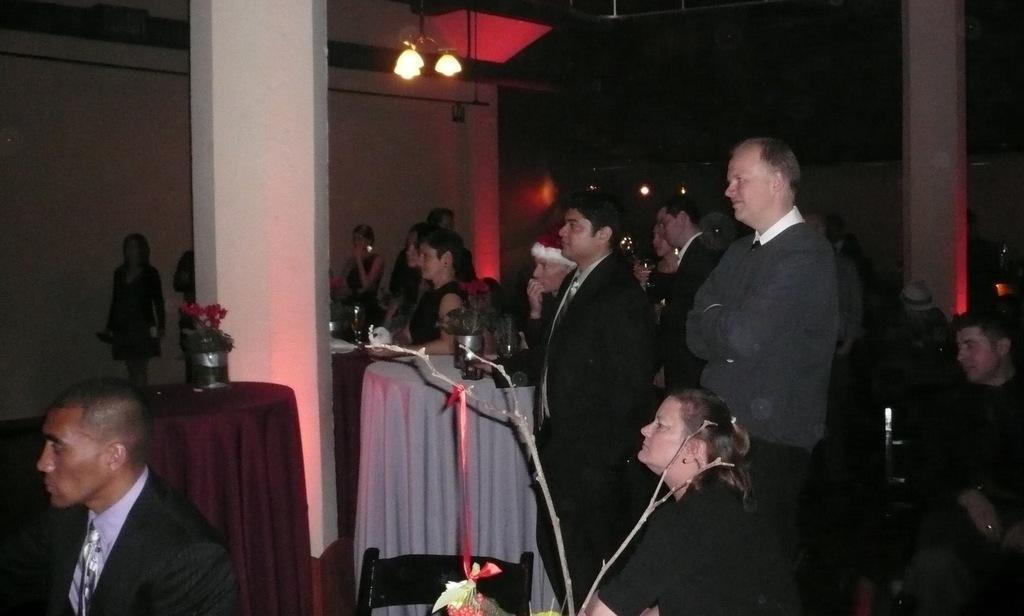Describe this image in one or two sentences. In this image in the front there are persons sitting and in the background there are persons standing and there are tables, on the table there are objects and there are lights on the top. In the front there are flowers and there is an empty chair. In the background there is a wall and there are lights.. 